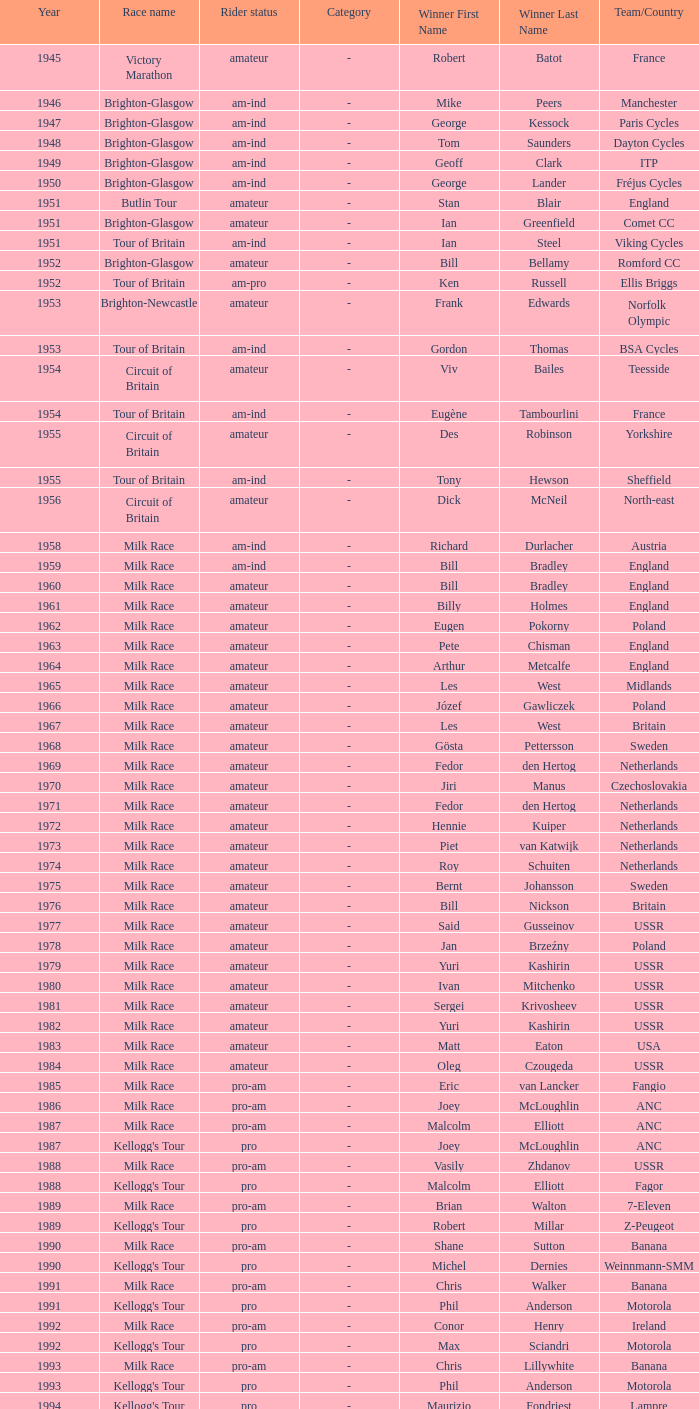What ream played later than 1958 in the kellogg's tour? ANC, Fagor, Z-Peugeot, Weinnmann-SMM, Motorola, Motorola, Motorola, Lampre. 